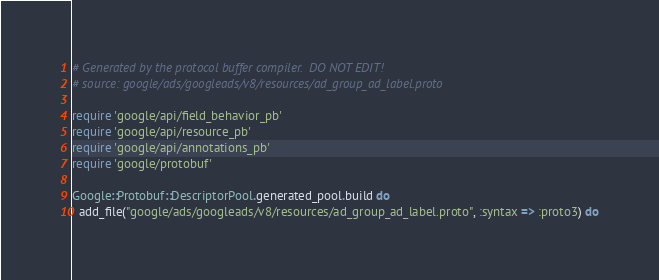Convert code to text. <code><loc_0><loc_0><loc_500><loc_500><_Ruby_># Generated by the protocol buffer compiler.  DO NOT EDIT!
# source: google/ads/googleads/v8/resources/ad_group_ad_label.proto

require 'google/api/field_behavior_pb'
require 'google/api/resource_pb'
require 'google/api/annotations_pb'
require 'google/protobuf'

Google::Protobuf::DescriptorPool.generated_pool.build do
  add_file("google/ads/googleads/v8/resources/ad_group_ad_label.proto", :syntax => :proto3) do</code> 